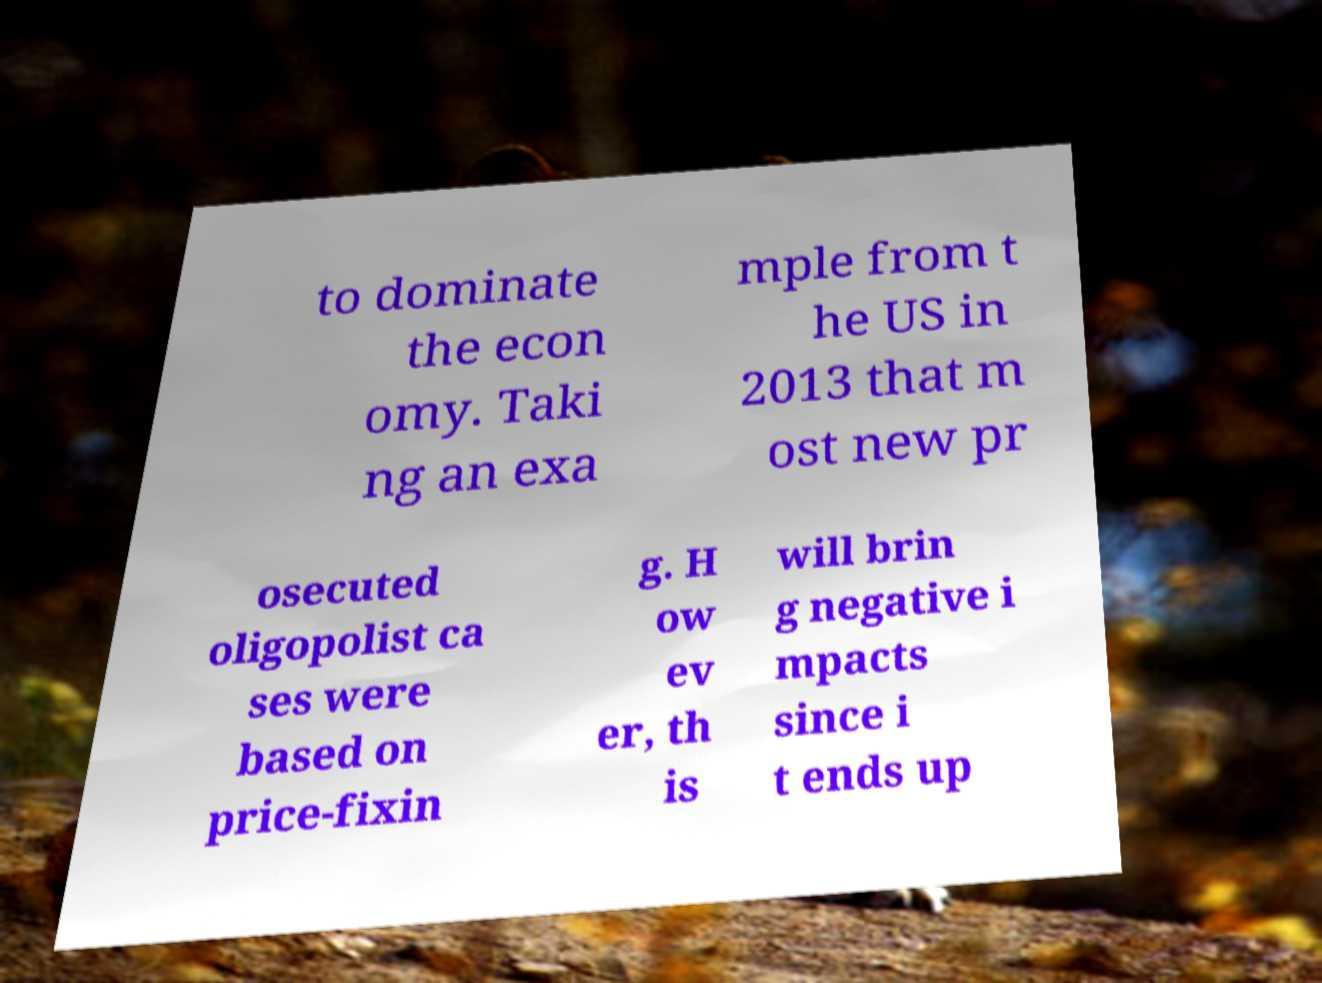Can you read and provide the text displayed in the image?This photo seems to have some interesting text. Can you extract and type it out for me? to dominate the econ omy. Taki ng an exa mple from t he US in 2013 that m ost new pr osecuted oligopolist ca ses were based on price-fixin g. H ow ev er, th is will brin g negative i mpacts since i t ends up 